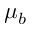Convert formula to latex. <formula><loc_0><loc_0><loc_500><loc_500>\mu _ { b }</formula> 